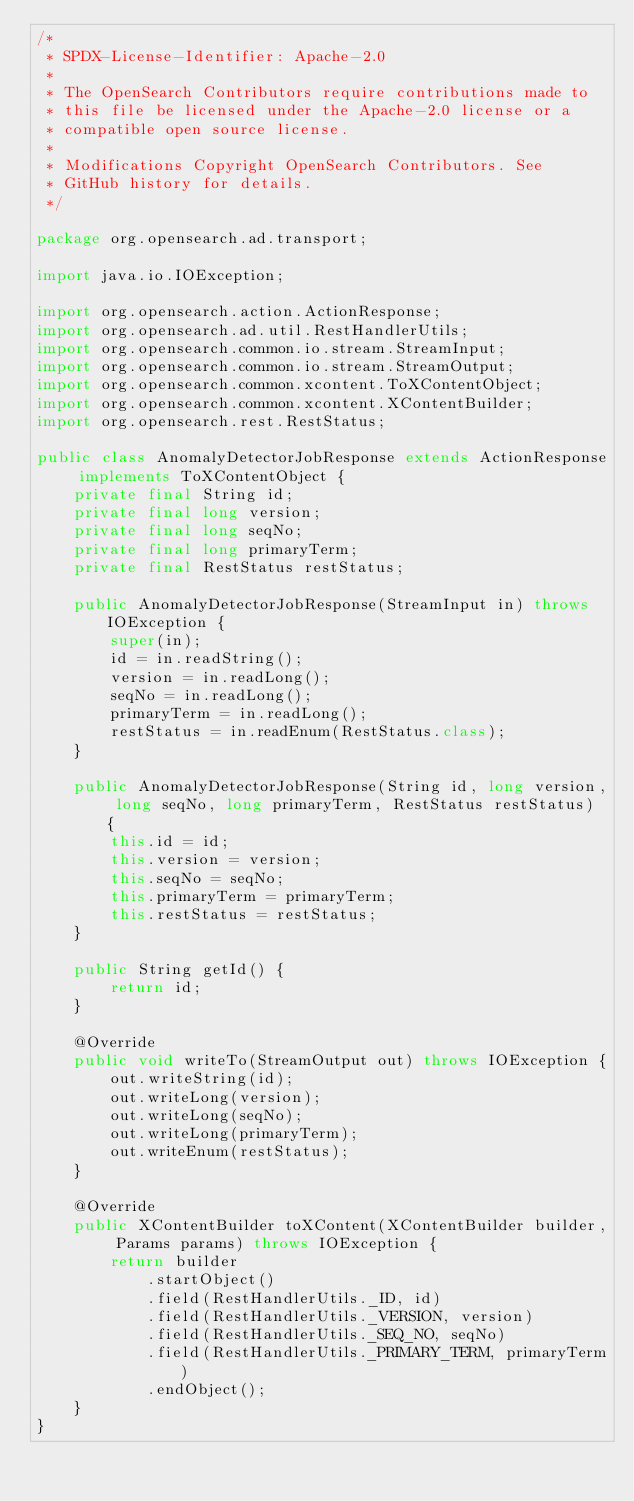Convert code to text. <code><loc_0><loc_0><loc_500><loc_500><_Java_>/*
 * SPDX-License-Identifier: Apache-2.0
 *
 * The OpenSearch Contributors require contributions made to
 * this file be licensed under the Apache-2.0 license or a
 * compatible open source license.
 *
 * Modifications Copyright OpenSearch Contributors. See
 * GitHub history for details.
 */

package org.opensearch.ad.transport;

import java.io.IOException;

import org.opensearch.action.ActionResponse;
import org.opensearch.ad.util.RestHandlerUtils;
import org.opensearch.common.io.stream.StreamInput;
import org.opensearch.common.io.stream.StreamOutput;
import org.opensearch.common.xcontent.ToXContentObject;
import org.opensearch.common.xcontent.XContentBuilder;
import org.opensearch.rest.RestStatus;

public class AnomalyDetectorJobResponse extends ActionResponse implements ToXContentObject {
    private final String id;
    private final long version;
    private final long seqNo;
    private final long primaryTerm;
    private final RestStatus restStatus;

    public AnomalyDetectorJobResponse(StreamInput in) throws IOException {
        super(in);
        id = in.readString();
        version = in.readLong();
        seqNo = in.readLong();
        primaryTerm = in.readLong();
        restStatus = in.readEnum(RestStatus.class);
    }

    public AnomalyDetectorJobResponse(String id, long version, long seqNo, long primaryTerm, RestStatus restStatus) {
        this.id = id;
        this.version = version;
        this.seqNo = seqNo;
        this.primaryTerm = primaryTerm;
        this.restStatus = restStatus;
    }

    public String getId() {
        return id;
    }

    @Override
    public void writeTo(StreamOutput out) throws IOException {
        out.writeString(id);
        out.writeLong(version);
        out.writeLong(seqNo);
        out.writeLong(primaryTerm);
        out.writeEnum(restStatus);
    }

    @Override
    public XContentBuilder toXContent(XContentBuilder builder, Params params) throws IOException {
        return builder
            .startObject()
            .field(RestHandlerUtils._ID, id)
            .field(RestHandlerUtils._VERSION, version)
            .field(RestHandlerUtils._SEQ_NO, seqNo)
            .field(RestHandlerUtils._PRIMARY_TERM, primaryTerm)
            .endObject();
    }
}
</code> 